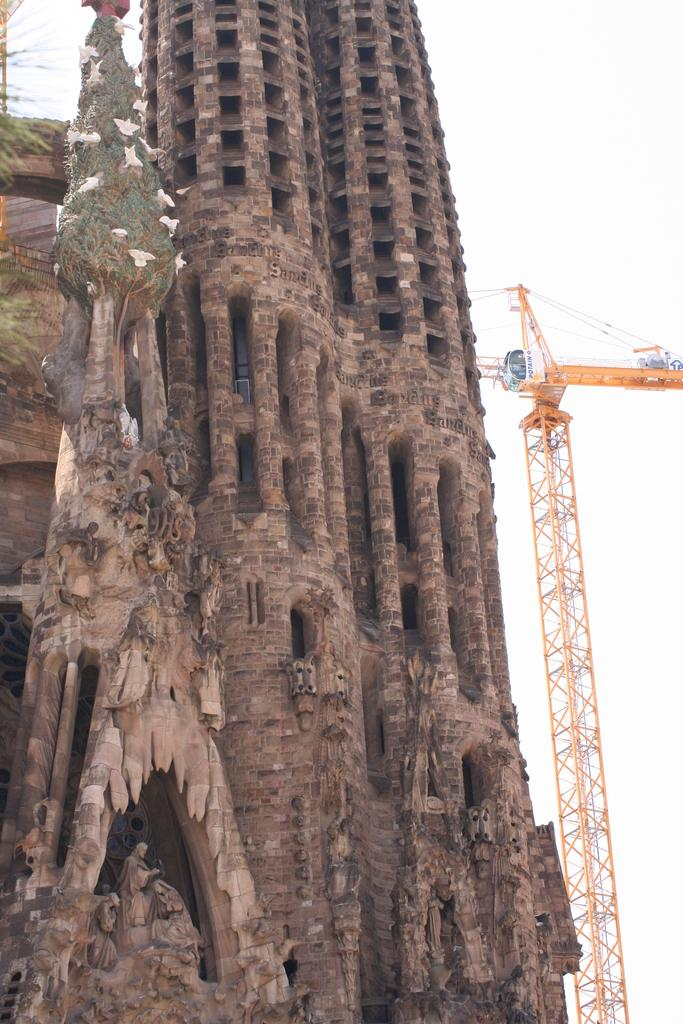What is the main subject in the center of the image? There is a crane in the center of the image. What type of structure can be seen in the image? There is a building in the image. What architectural elements are present in the image? There are pillars in the image. What artistic features can be observed in the image? There are sculptures in the image. What type of rabbit can be seen hiding behind the pillar in the image? There is no rabbit present in the image; it only features a crane, a building, pillars, and sculptures. 